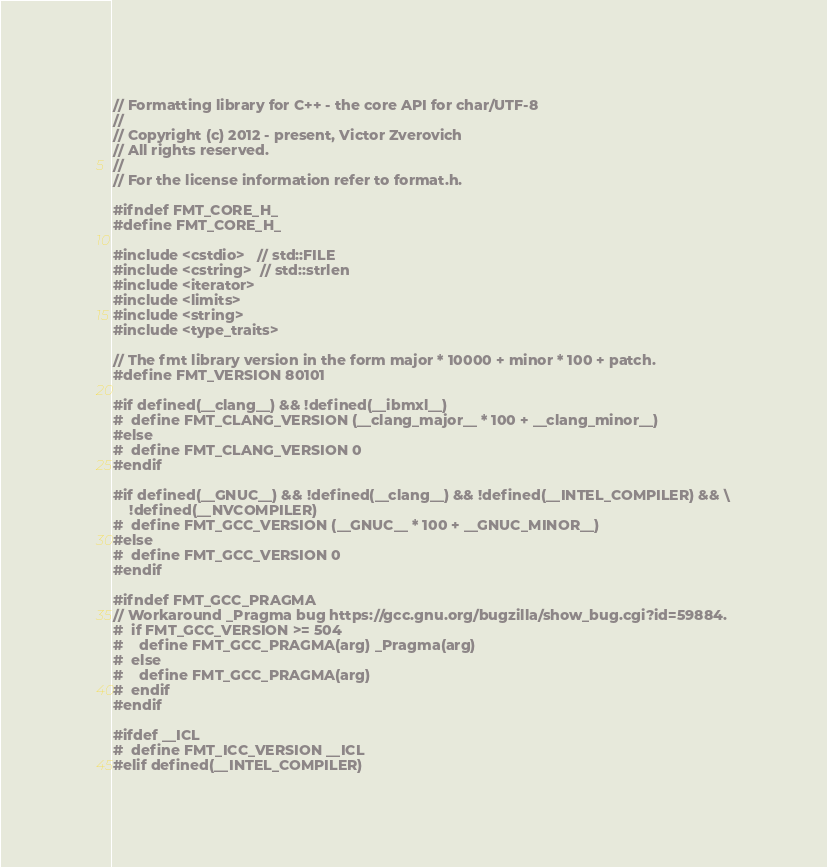Convert code to text. <code><loc_0><loc_0><loc_500><loc_500><_C_>// Formatting library for C++ - the core API for char/UTF-8
//
// Copyright (c) 2012 - present, Victor Zverovich
// All rights reserved.
//
// For the license information refer to format.h.

#ifndef FMT_CORE_H_
#define FMT_CORE_H_

#include <cstdio>   // std::FILE
#include <cstring>  // std::strlen
#include <iterator>
#include <limits>
#include <string>
#include <type_traits>

// The fmt library version in the form major * 10000 + minor * 100 + patch.
#define FMT_VERSION 80101

#if defined(__clang__) && !defined(__ibmxl__)
#  define FMT_CLANG_VERSION (__clang_major__ * 100 + __clang_minor__)
#else
#  define FMT_CLANG_VERSION 0
#endif

#if defined(__GNUC__) && !defined(__clang__) && !defined(__INTEL_COMPILER) && \
    !defined(__NVCOMPILER)
#  define FMT_GCC_VERSION (__GNUC__ * 100 + __GNUC_MINOR__)
#else
#  define FMT_GCC_VERSION 0
#endif

#ifndef FMT_GCC_PRAGMA
// Workaround _Pragma bug https://gcc.gnu.org/bugzilla/show_bug.cgi?id=59884.
#  if FMT_GCC_VERSION >= 504
#    define FMT_GCC_PRAGMA(arg) _Pragma(arg)
#  else
#    define FMT_GCC_PRAGMA(arg)
#  endif
#endif

#ifdef __ICL
#  define FMT_ICC_VERSION __ICL
#elif defined(__INTEL_COMPILER)</code> 